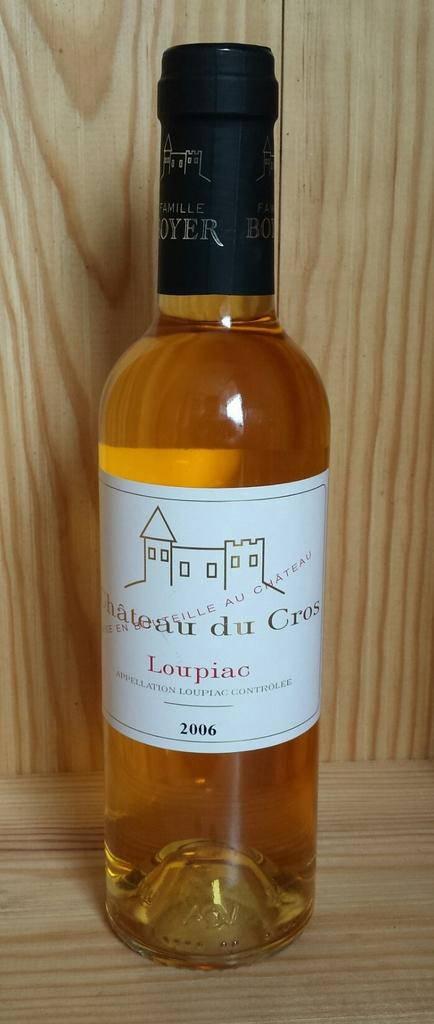<image>
Offer a succinct explanation of the picture presented. a bottle with Loupiac on it and a white background 